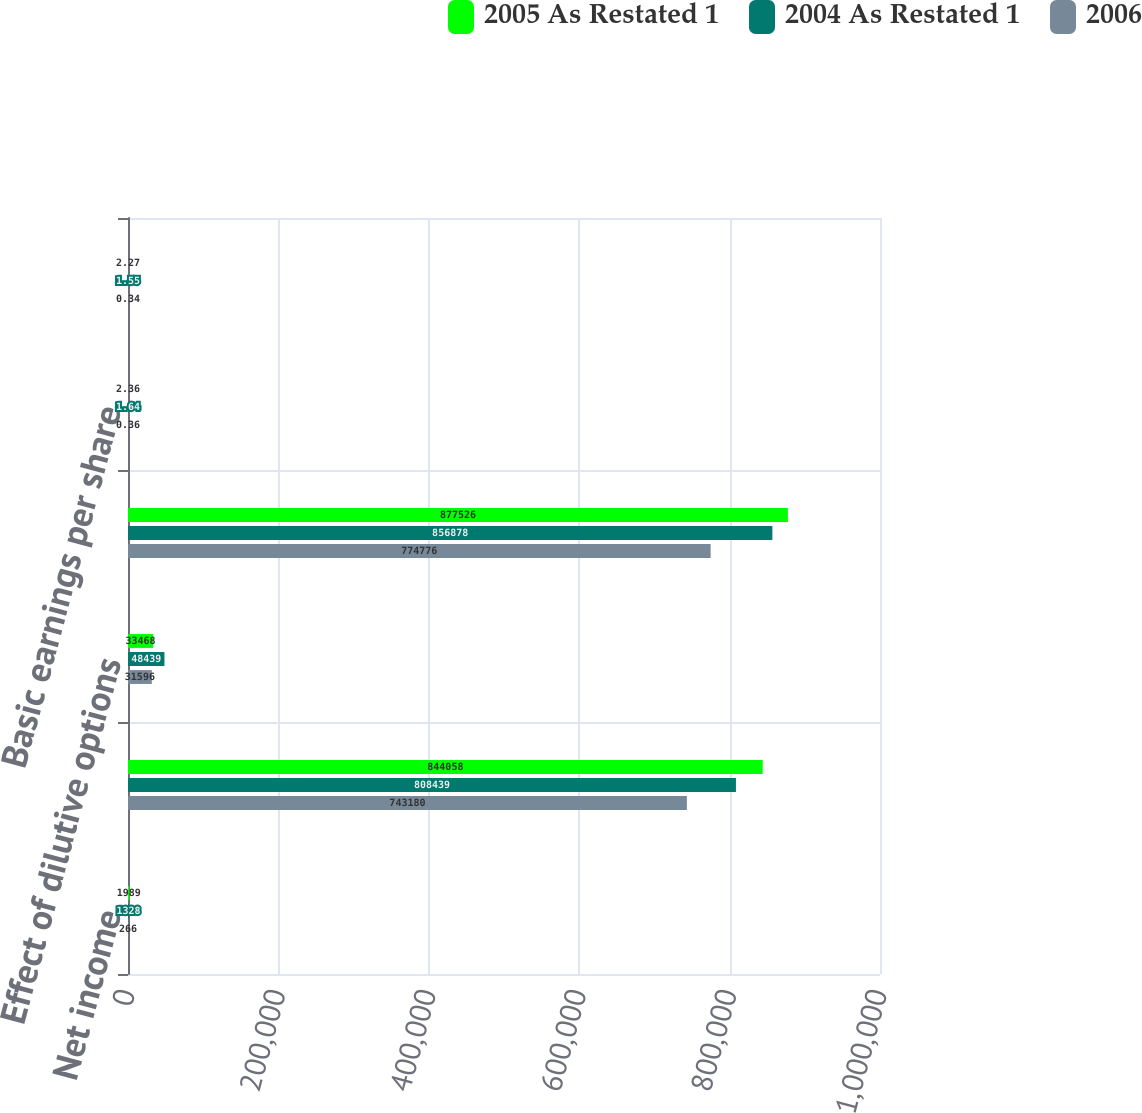Convert chart. <chart><loc_0><loc_0><loc_500><loc_500><stacked_bar_chart><ecel><fcel>Net income<fcel>Weighted-average shares<fcel>Effect of dilutive options<fcel>Denominator for diluted<fcel>Basic earnings per share<fcel>Diluted earnings per share<nl><fcel>2005 As Restated 1<fcel>1989<fcel>844058<fcel>33468<fcel>877526<fcel>2.36<fcel>2.27<nl><fcel>2004 As Restated 1<fcel>1328<fcel>808439<fcel>48439<fcel>856878<fcel>1.64<fcel>1.55<nl><fcel>2006<fcel>266<fcel>743180<fcel>31596<fcel>774776<fcel>0.36<fcel>0.34<nl></chart> 